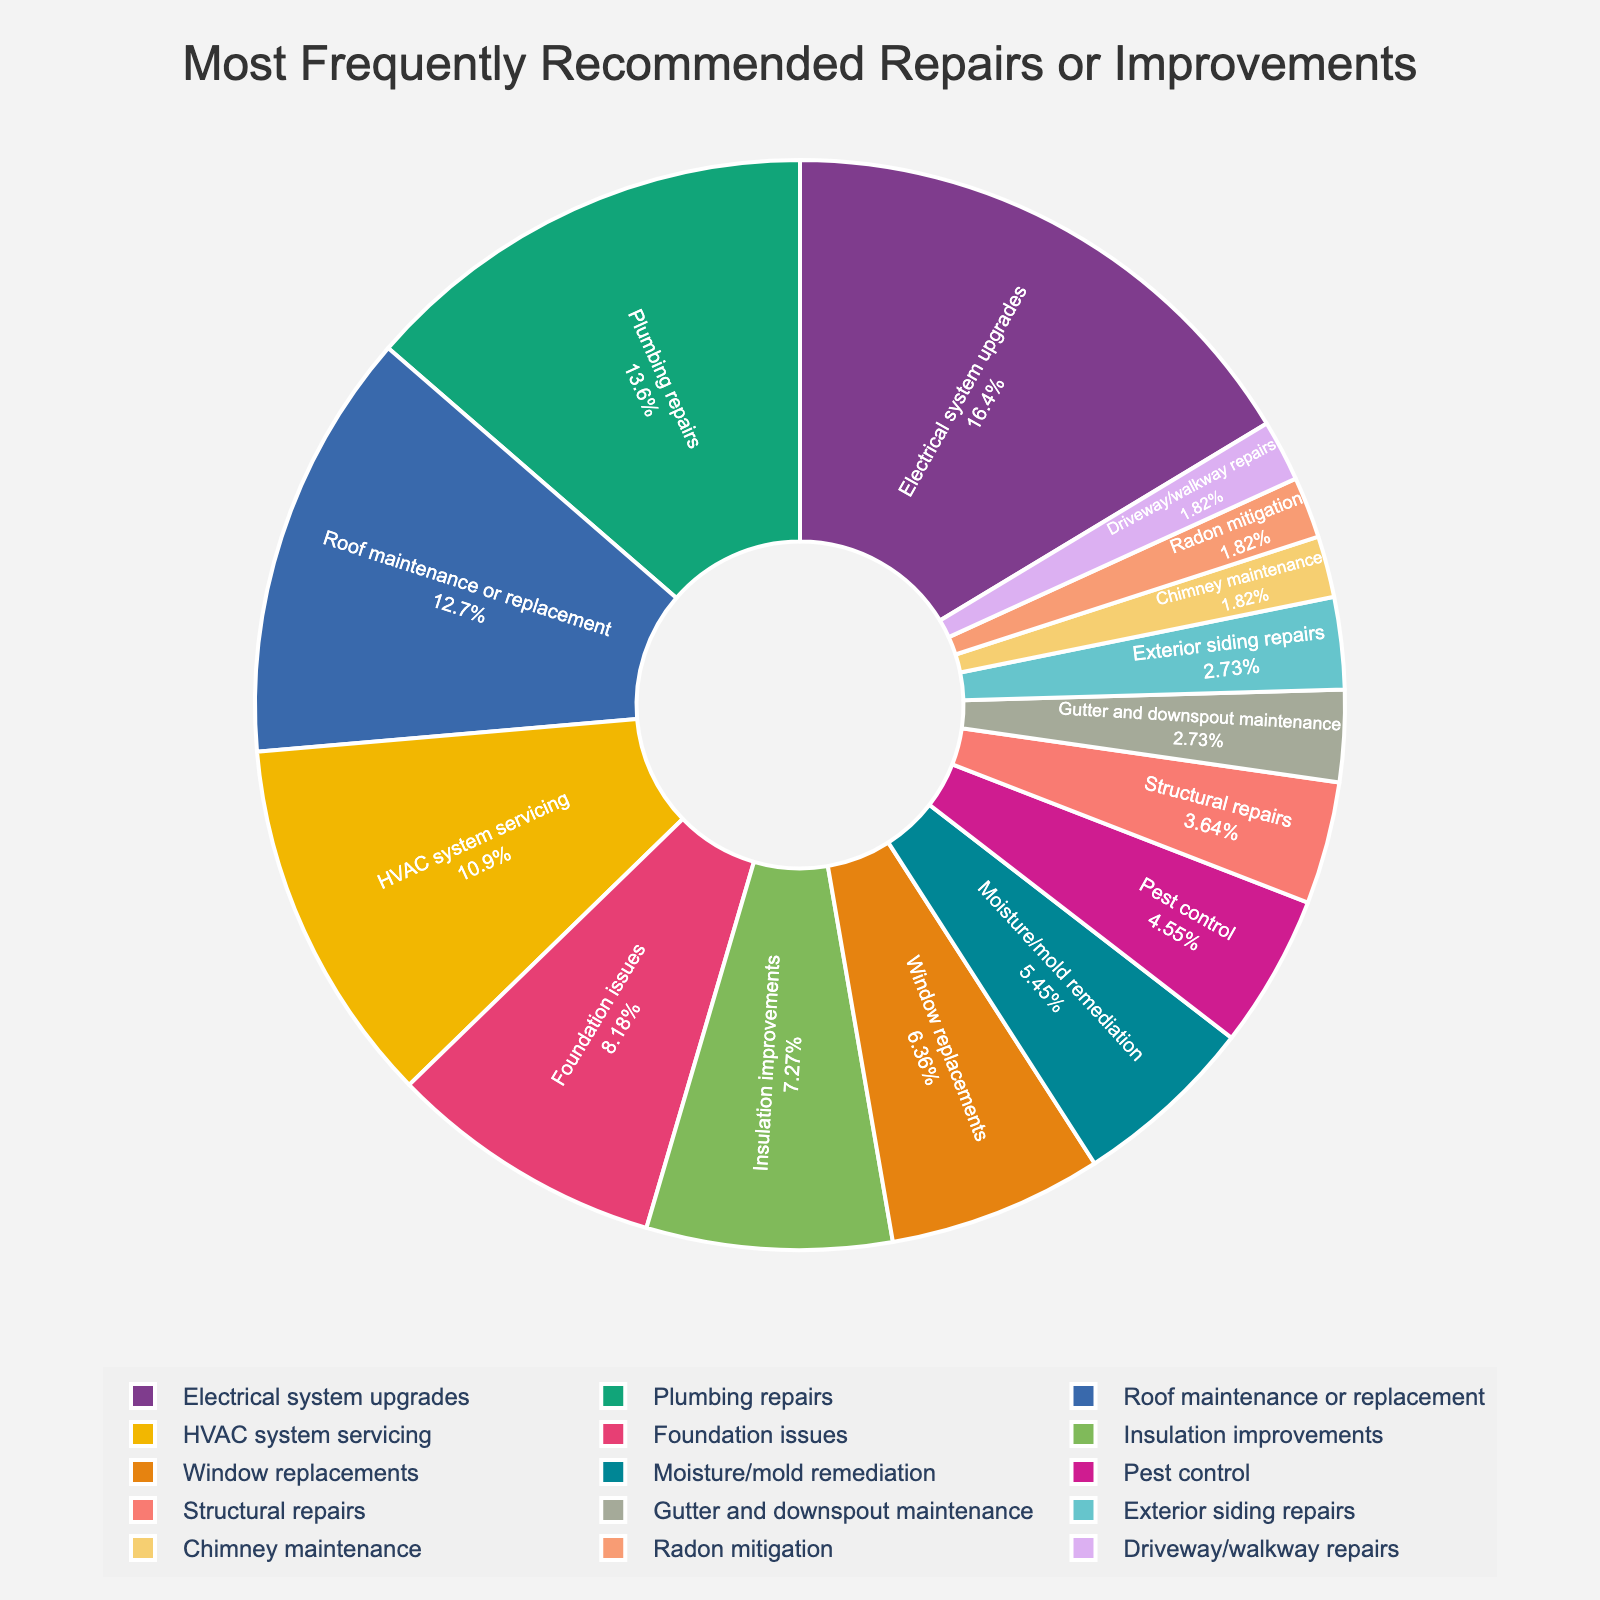Which category had the highest percentage recommendation? "Electrical system upgrades" has the largest section in the pie chart. Hence, it has the highest percentage.
Answer: Electrical system upgrades Which two categories had a combined recommendation percentage of 29%? Add the percentages for "Plumbing repairs" at 15% and "HVAC system servicing" at 12%. 15% + 12% = 27%. Add one more category with a small percentage: "Gutter and downspout maintenance" at 3%. Thus, 15% + 12% + 3% = 30%. Therefore, the next closest is "Roof maintenance or replacement" at 14% and "Foundation issues" at 9%. Thus, "Roof maintenance or replacement": 14% and "Foundation issues": 9% equals "23%"
Answer: Plumbing repairs & Foundation issues Which is recommended more: Window replacements or Insulation improvements? Comparing the slices of the pie chart, insulation improvements have a larger portion than window replacements.
Answer: Insulation improvements What is the total percentage for the categories related to external improvements (Roof maintenance, Window replacements, Exterior siding repairs, Driveway/walkway repairs)? Sum the percentages of "Roof maintenance or replacement" (14%), "Window replacements" (7%), "Exterior siding repairs" (3%), "Driveway/walkway repairs" (2%). The result is 14% + 7% + 3% + 2% = 26%.
Answer: 26% Which category is represented by the smallest slice in the pie chart? "Chimney maintenance", "Radon mitigation", and "Driveway/walkway repairs" all share the smallest slice at 2%.
Answer: Chimney maintenance How much more frequently are Electrical system upgrades recommended compared to Pest control? Electrical system upgrades are 18% and Pest control is 5%. Subtract the percentage of Pest control from Electrical system upgrades, which is 18% - 5% = 13%.
Answer: 13% Enumerate the categories with percentages less than 5%. From the pie chart, the portions with percentages less than 5% are: "Structural repairs" (4%), "Gutter and downspout maintenance" (3%), "Exterior siding repairs" (3%), "Chimney maintenance" (2%), "Radon mitigation" (2%), "Driveway/walkway repairs" (also 2%).
Answer: Structural repairs, Gutter and downspout maintenance, Exterior siding repairs, Chimney maintenance, Radon mitigation, Driveway/walkway repairs Which has a larger slice: Insulation improvements or Moisture/mold remediation? Insulation improvements have a percentage of 8%, while moisture/mold remediation has 6%. Insulation improvements have a larger slice.
Answer: Insulation improvements 